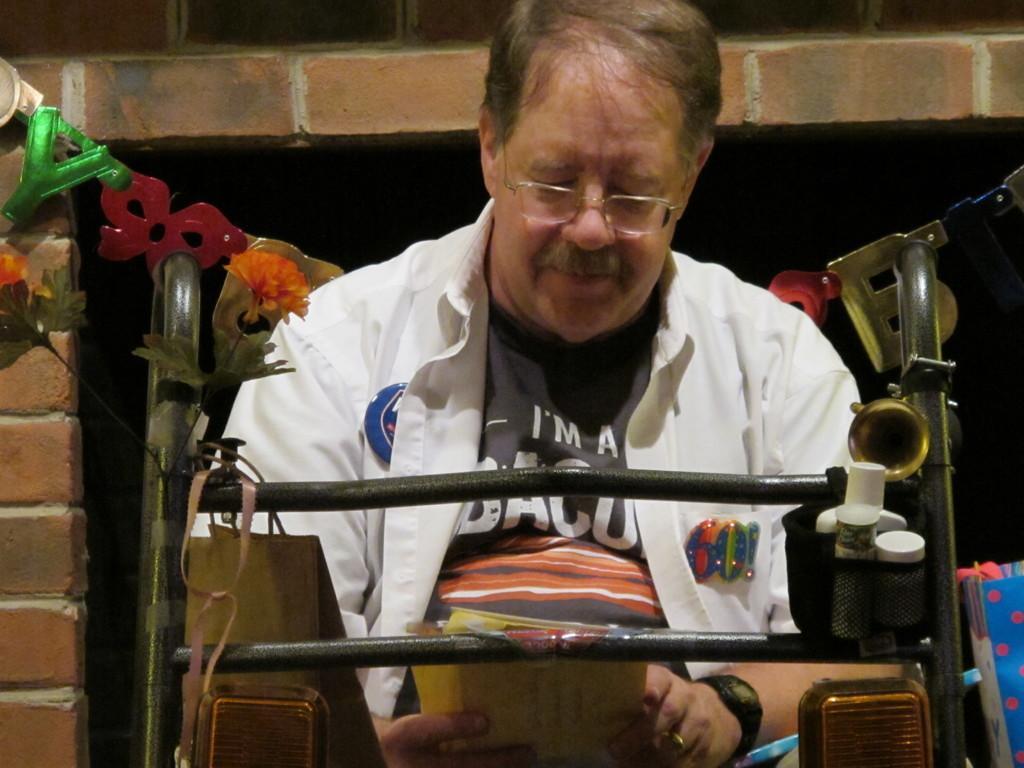Please provide a concise description of this image. In this picture we can see a person, he is wearing a spectacles, watch and holding an object, here we can see a wall, decorative objects and some objects and in the background we can see it is dark. 